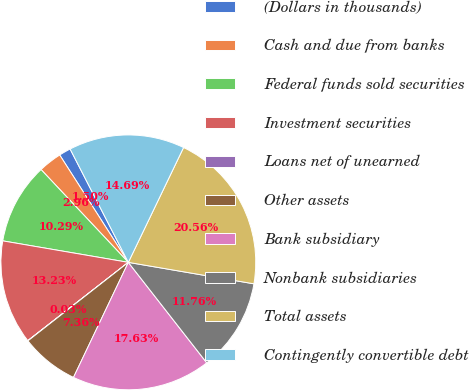Convert chart. <chart><loc_0><loc_0><loc_500><loc_500><pie_chart><fcel>(Dollars in thousands)<fcel>Cash and due from banks<fcel>Federal funds sold securities<fcel>Investment securities<fcel>Loans net of unearned<fcel>Other assets<fcel>Bank subsidiary<fcel>Nonbank subsidiaries<fcel>Total assets<fcel>Contingently convertible debt<nl><fcel>1.5%<fcel>2.96%<fcel>10.29%<fcel>13.23%<fcel>0.03%<fcel>7.36%<fcel>17.63%<fcel>11.76%<fcel>20.56%<fcel>14.69%<nl></chart> 